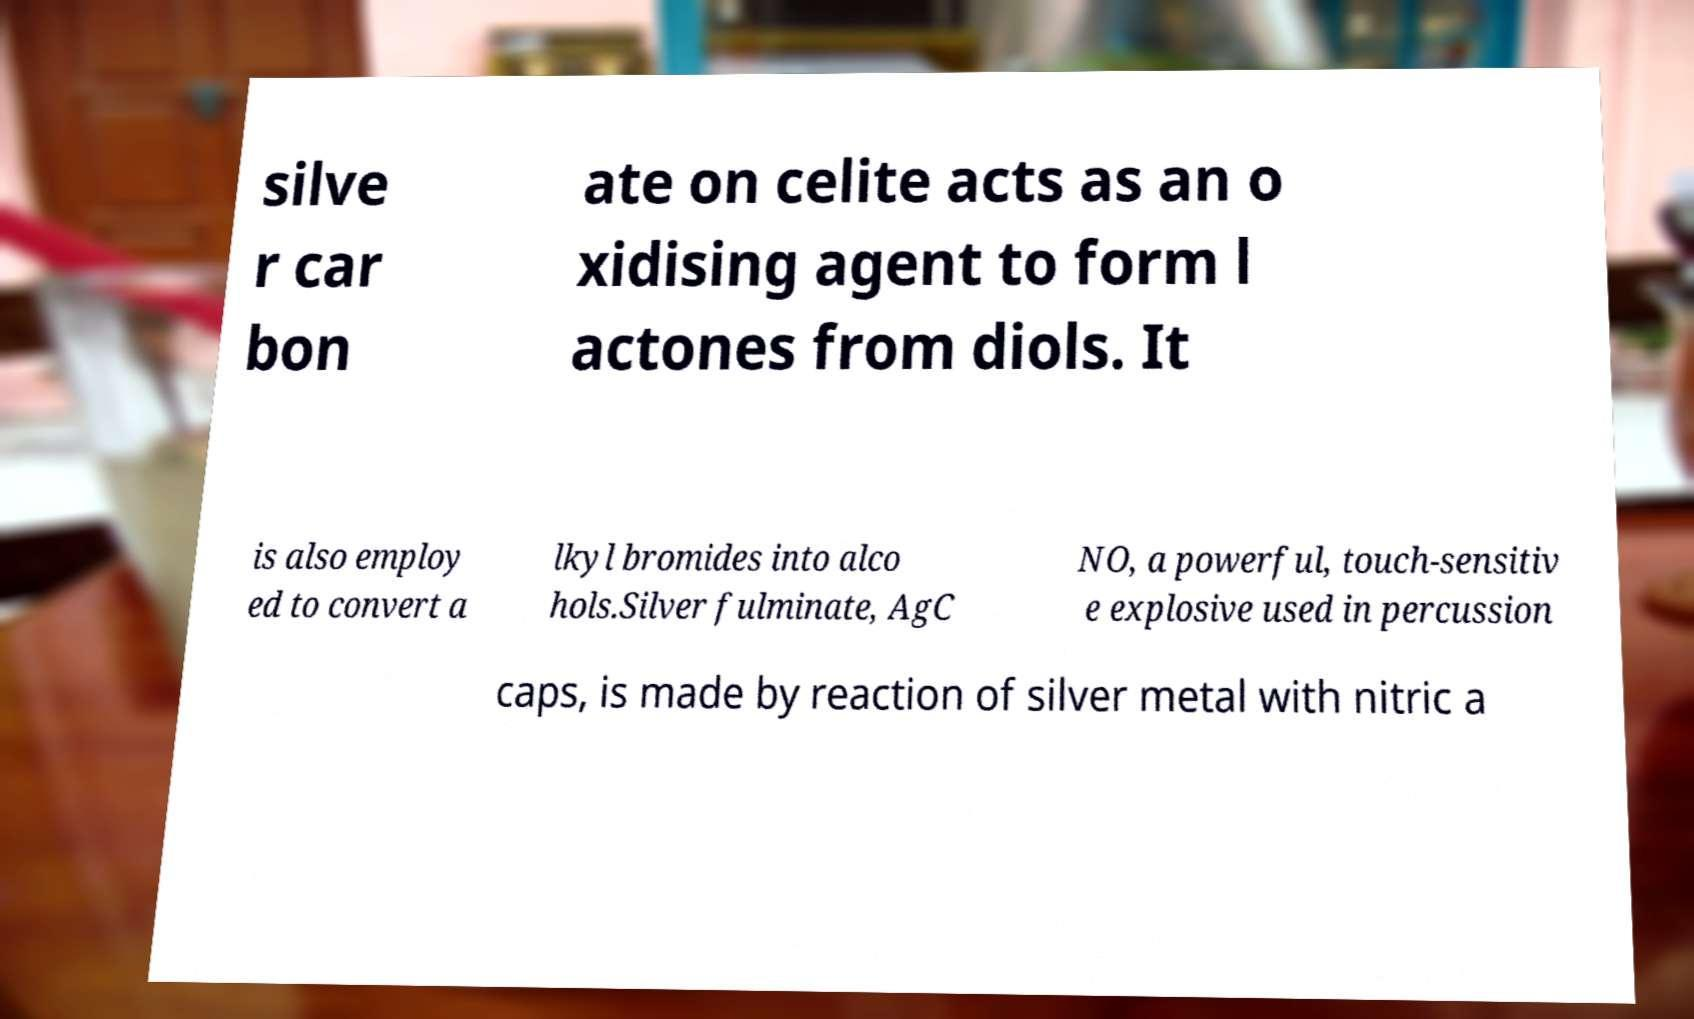Could you extract and type out the text from this image? silve r car bon ate on celite acts as an o xidising agent to form l actones from diols. It is also employ ed to convert a lkyl bromides into alco hols.Silver fulminate, AgC NO, a powerful, touch-sensitiv e explosive used in percussion caps, is made by reaction of silver metal with nitric a 